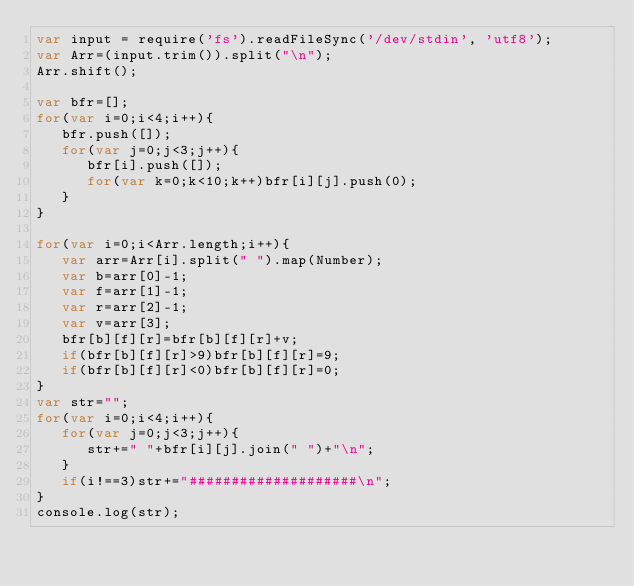Convert code to text. <code><loc_0><loc_0><loc_500><loc_500><_JavaScript_>var input = require('fs').readFileSync('/dev/stdin', 'utf8');
var Arr=(input.trim()).split("\n");
Arr.shift();
  
var bfr=[];
for(var i=0;i<4;i++){
   bfr.push([]);
   for(var j=0;j<3;j++){
      bfr[i].push([]);
      for(var k=0;k<10;k++)bfr[i][j].push(0);
   }
}
  
for(var i=0;i<Arr.length;i++){
   var arr=Arr[i].split(" ").map(Number);
   var b=arr[0]-1;
   var f=arr[1]-1;
   var r=arr[2]-1;
   var v=arr[3];
   bfr[b][f][r]=bfr[b][f][r]+v;
   if(bfr[b][f][r]>9)bfr[b][f][r]=9;
   if(bfr[b][f][r]<0)bfr[b][f][r]=0;
}
var str="";
for(var i=0;i<4;i++){
   for(var j=0;j<3;j++){
      str+=" "+bfr[i][j].join(" ")+"\n";
   }
   if(i!==3)str+="####################\n";
}
console.log(str);</code> 